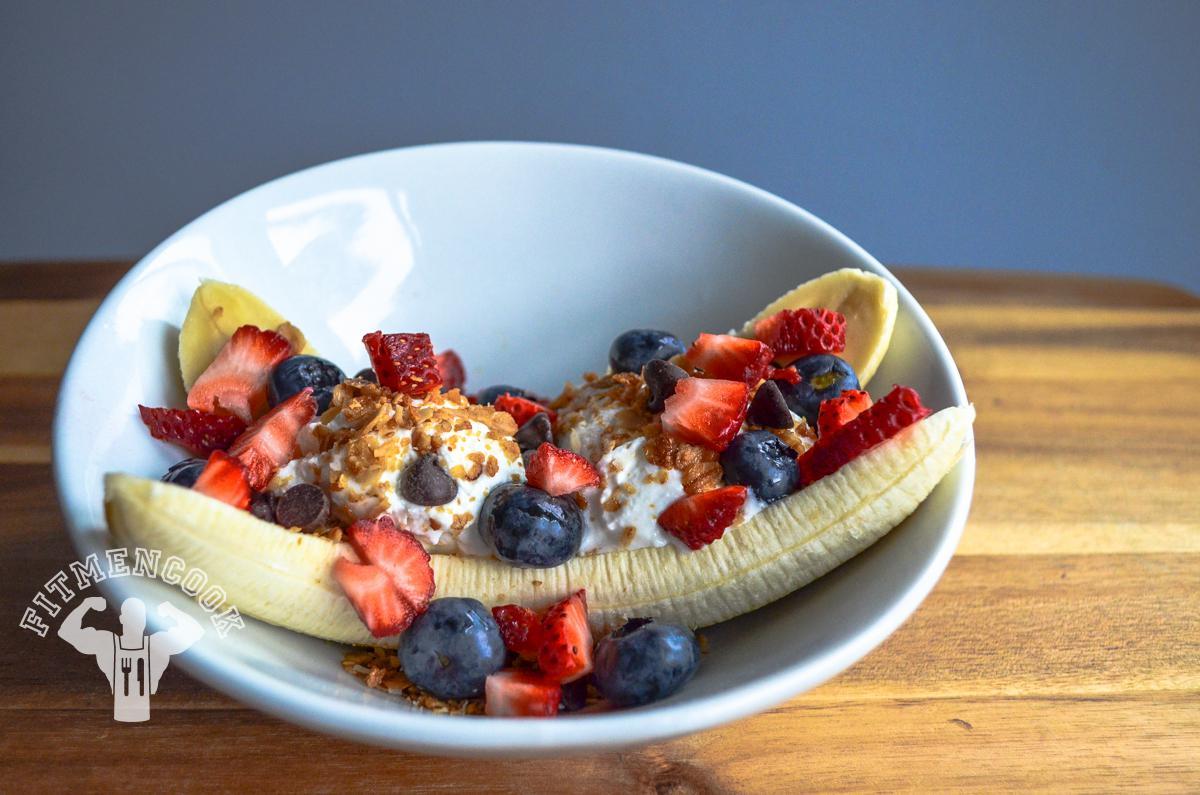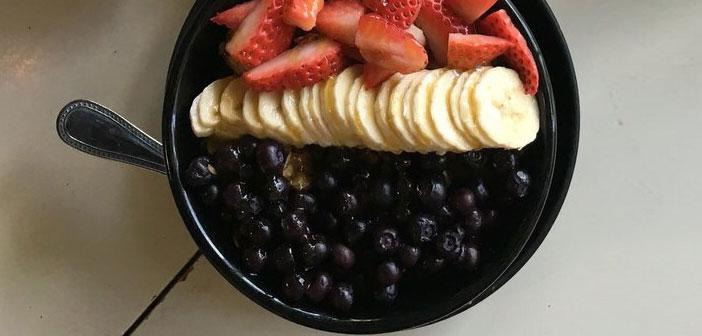The first image is the image on the left, the second image is the image on the right. For the images displayed, is the sentence "There are round banana slices." factually correct? Answer yes or no. Yes. 